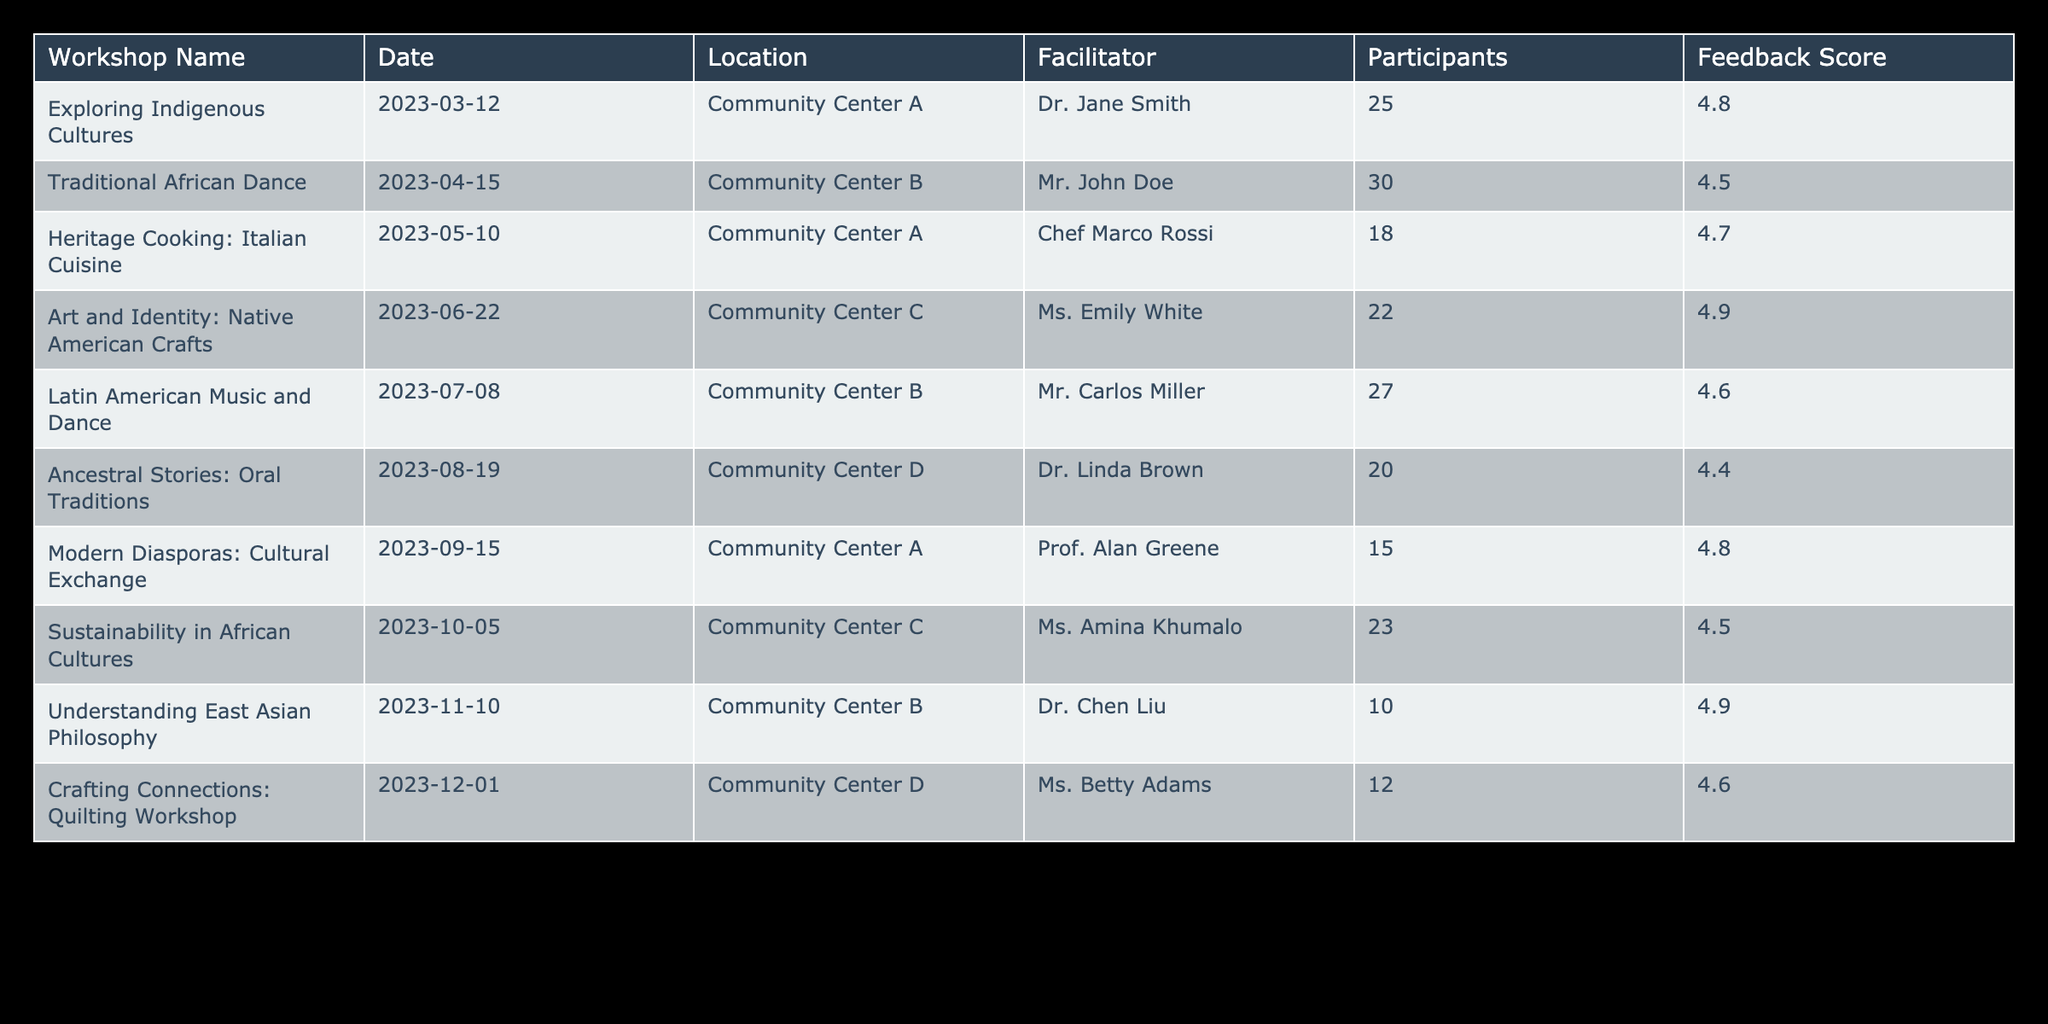What was the feedback score for the workshop on Traditional African Dance? The table lists the feedback scores for each workshop. For the workshop titled "Traditional African Dance," the corresponding feedback score is given as 4.5.
Answer: 4.5 Which workshop had the highest number of participants? By examining the Participants column, the highest number of participants is found in "Traditional African Dance" with 30 participants, more than any other workshop listed.
Answer: Traditional African Dance What is the average feedback score for all workshops held in 2023? To find the average feedback score, first, we sum all feedback scores: 4.8 + 4.5 + 4.7 + 4.9 + 4.6 + 4.4 + 4.8 + 4.5 + 4.9 + 4.6 = 46.7. There are 10 workshops, so the average is 46.7 / 10 = 4.67.
Answer: 4.67 Did the workshop on Understanding East Asian Philosophy receive a feedback score of more than 4.5? The table shows that the feedback score for the "Understanding East Asian Philosophy" workshop is 4.9, which is indeed greater than 4.5.
Answer: Yes What is the total number of participants across all workshops held in Community Center A? We need to filter the workshops that were held in Community Center A. The workshops there are "Exploring Indigenous Cultures" (25 participants) and "Modern Diasporas: Cultural Exchange" (15 participants). Adding these gives 25 + 15 = 40 participants in total.
Answer: 40 Which facilitator led the workshop with the lowest number of participants? By looking at the Participants column, the workshop with the lowest attendance is "Understanding East Asian Philosophy" with 10 participants, facilitated by Dr. Chen Liu.
Answer: Dr. Chen Liu How many workshops offered feedback scores of 4.7 or higher? We need to count the workshops where the Feedback Score is 4.7 or higher. Reviewing the scores, five workshops meet this criterion: "Exploring Indigenous Cultures," "Heritage Cooking: Italian Cuisine," "Art and Identity: Native American Crafts," "Latin American Music and Dance," and "Understanding East Asian Philosophy." Thus, there are 5 workshops in total that fit this description.
Answer: 5 What percentage of workshops had a feedback score of 4.6 or above? First, we calculate how many workshops had a feedback score of 4.6 or higher: these are 8 workshops. Since there are 10 workshops in total, we calculate the percentage as (8/10) * 100 = 80%.
Answer: 80% Which workshop had fewer than 15 participants? The "Understanding East Asian Philosophy" workshop is the only one with fewer than 15 participants, having 10 participants according to the table.
Answer: Understanding East Asian Philosophy 